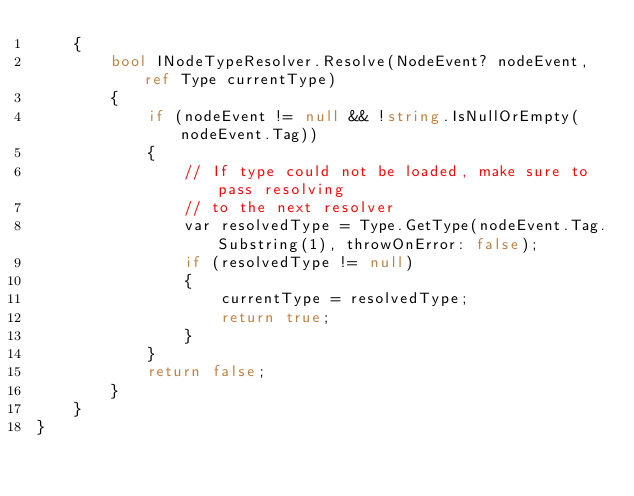<code> <loc_0><loc_0><loc_500><loc_500><_C#_>    {
        bool INodeTypeResolver.Resolve(NodeEvent? nodeEvent, ref Type currentType)
        {
            if (nodeEvent != null && !string.IsNullOrEmpty(nodeEvent.Tag))
            {
                // If type could not be loaded, make sure to pass resolving
                // to the next resolver
                var resolvedType = Type.GetType(nodeEvent.Tag.Substring(1), throwOnError: false);
                if (resolvedType != null)
                {
                    currentType = resolvedType;
                    return true;
                }
            }
            return false;
        }
    }
}
</code> 